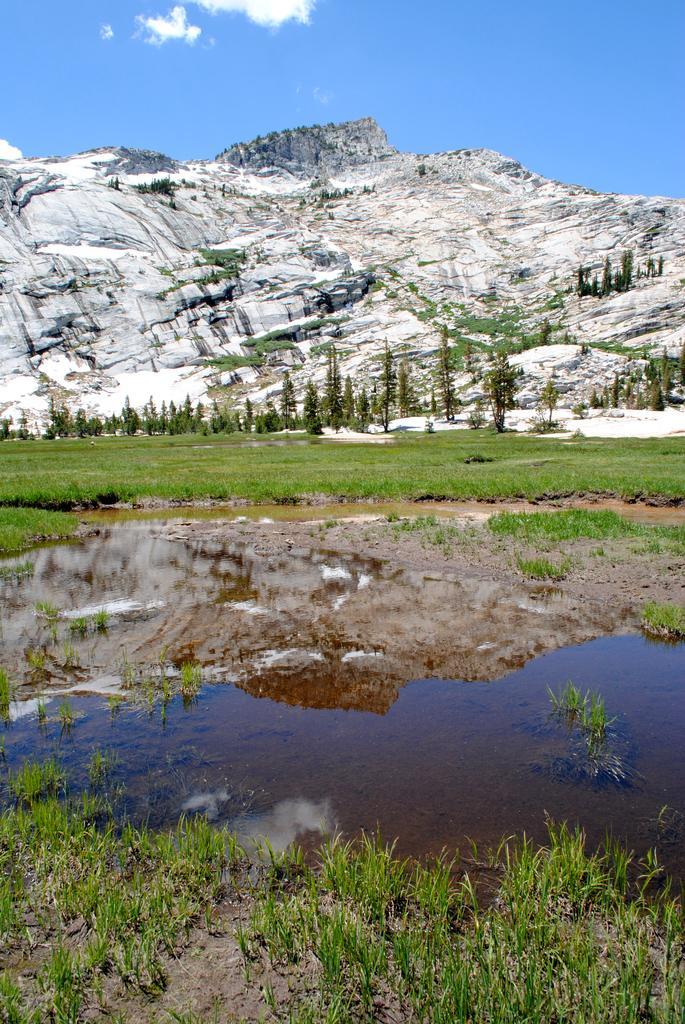Could you give a brief overview of what you see in this image? This image is taken outdoors. At the top of the image there is a sky with clouds. At the bottom of the image there is a ground with grass on it. In the middle of the image there is a pond with water. In the background there are a few hills covered with snow and there are a few trees and plants on the ground. 